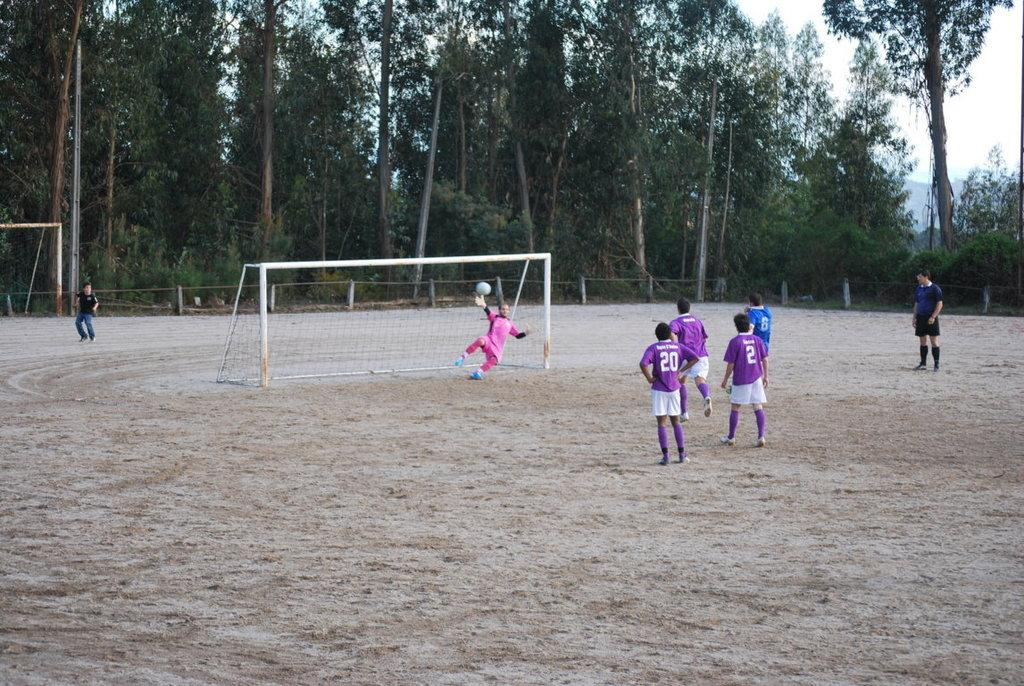Provide a one-sentence caption for the provided image. Players 2 and 20 stand near each other watching the goalie. 